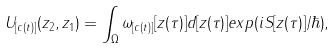Convert formula to latex. <formula><loc_0><loc_0><loc_500><loc_500>U _ { [ c ( t ) ] } ( z _ { 2 } , z _ { 1 } ) = \int _ { \Omega } \omega _ { [ c ( t ) ] } [ z ( \tau ) ] d [ z ( \tau ) ] e x p ( i S [ z ( \tau ) ] / \hbar { ) } ,</formula> 